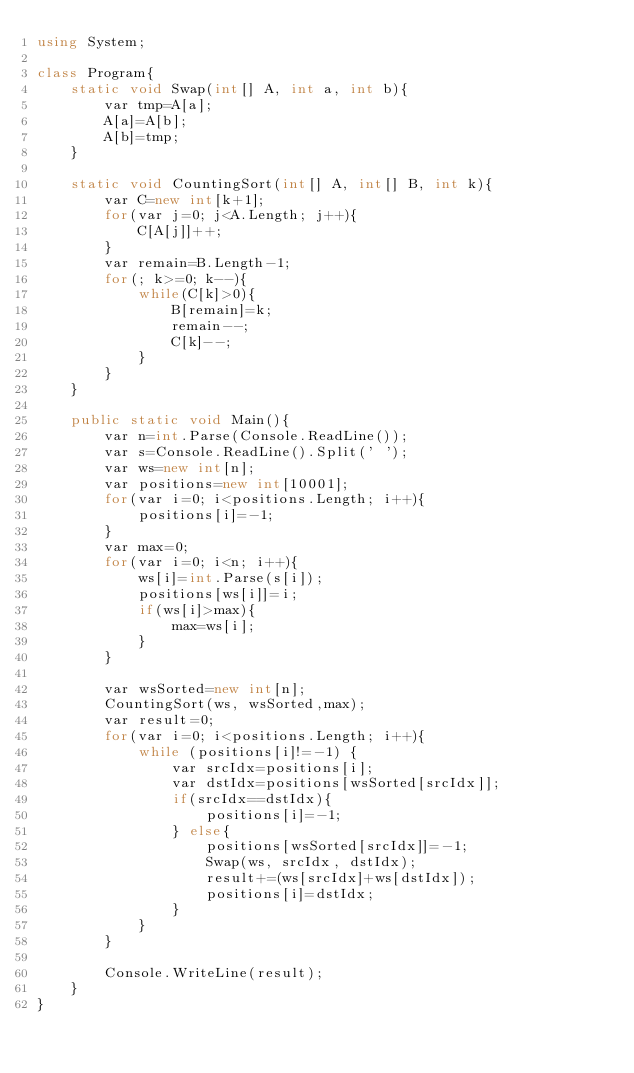<code> <loc_0><loc_0><loc_500><loc_500><_C#_>using System;

class Program{
    static void Swap(int[] A, int a, int b){
        var tmp=A[a];
        A[a]=A[b];
        A[b]=tmp;
    }

    static void CountingSort(int[] A, int[] B, int k){
        var C=new int[k+1];
        for(var j=0; j<A.Length; j++){
            C[A[j]]++;
        }
        var remain=B.Length-1;
        for(; k>=0; k--){
            while(C[k]>0){
                B[remain]=k;
                remain--;
                C[k]--;
            }
        }
    }

    public static void Main(){
        var n=int.Parse(Console.ReadLine());
        var s=Console.ReadLine().Split(' ');
        var ws=new int[n];
        var positions=new int[10001];
        for(var i=0; i<positions.Length; i++){
            positions[i]=-1;
        }
        var max=0;
        for(var i=0; i<n; i++){
            ws[i]=int.Parse(s[i]);
            positions[ws[i]]=i;
            if(ws[i]>max){
                max=ws[i];
            }
        }

        var wsSorted=new int[n];
        CountingSort(ws, wsSorted,max);
        var result=0;
        for(var i=0; i<positions.Length; i++){
            while (positions[i]!=-1) {
                var srcIdx=positions[i];
                var dstIdx=positions[wsSorted[srcIdx]];
                if(srcIdx==dstIdx){
                    positions[i]=-1;
                } else{
                    positions[wsSorted[srcIdx]]=-1;
                    Swap(ws, srcIdx, dstIdx);
                    result+=(ws[srcIdx]+ws[dstIdx]);
                    positions[i]=dstIdx;
                }
            }
        }

        Console.WriteLine(result);
    }
}</code> 